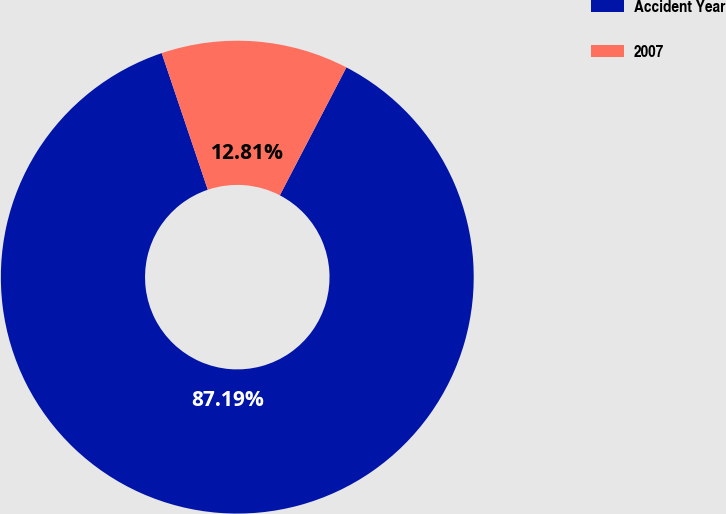Convert chart to OTSL. <chart><loc_0><loc_0><loc_500><loc_500><pie_chart><fcel>Accident Year<fcel>2007<nl><fcel>87.19%<fcel>12.81%<nl></chart> 